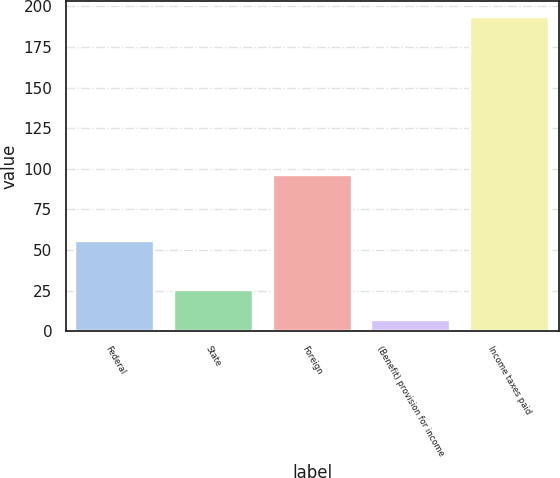Convert chart to OTSL. <chart><loc_0><loc_0><loc_500><loc_500><bar_chart><fcel>Federal<fcel>State<fcel>Foreign<fcel>(Benefit) provision for income<fcel>Income taxes paid<nl><fcel>55.8<fcel>25.66<fcel>96.3<fcel>7<fcel>193.6<nl></chart> 